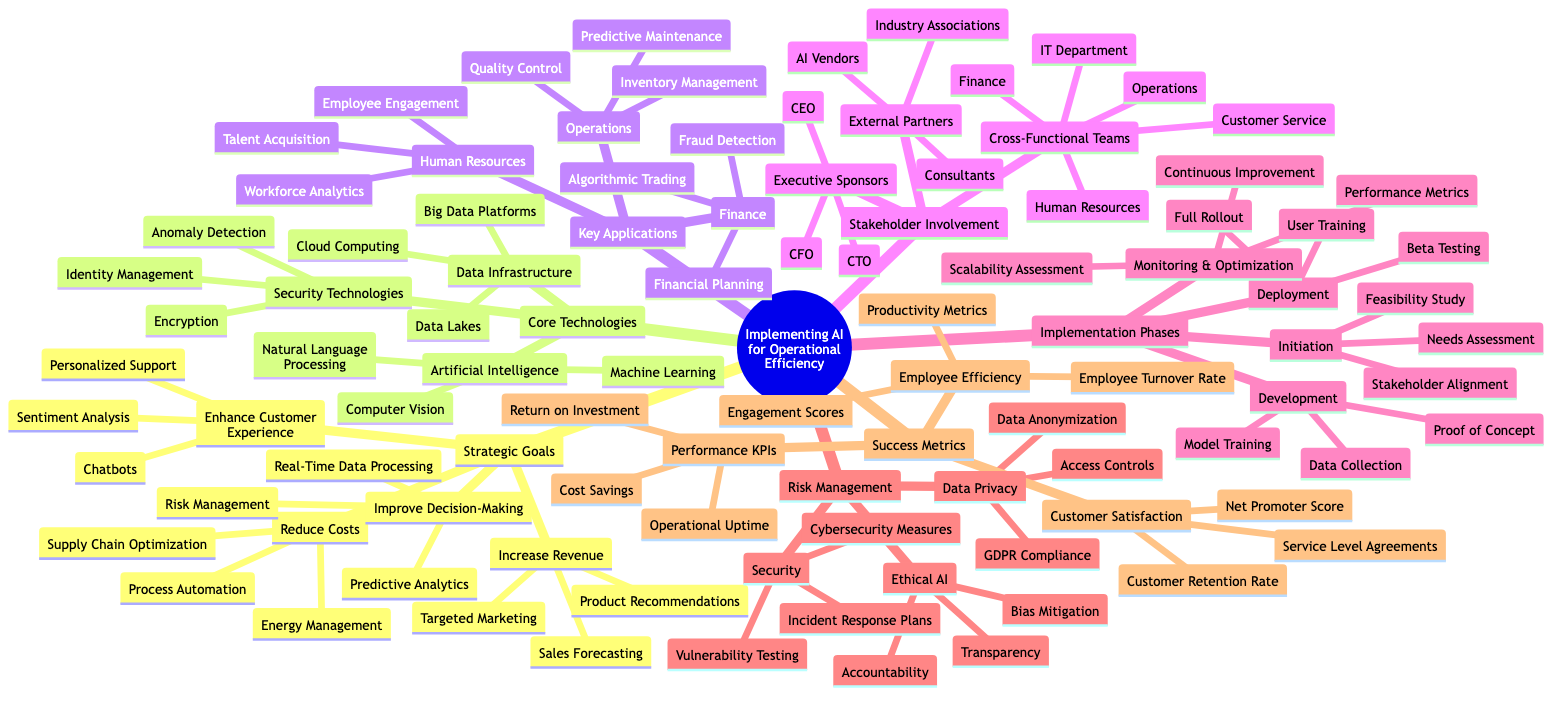What are the four strategic goals outlined in the mind map? The diagram lists four strategic goals: Increase Revenue, Reduce Costs, Enhance Customer Experience, and Improve Decision-Making.
Answer: Increase Revenue, Reduce Costs, Enhance Customer Experience, Improve Decision-Making How many core technologies are listed in the diagram? The mind map presents three core technology categories: Artificial Intelligence, Data Infrastructure, and Security Technologies. This totals to three categories.
Answer: Three What is the first application listed under Human Resources? The first application mentioned under Human Resources is Talent Acquisition.
Answer: Talent Acquisition What are the key applications in Operations? The mind map specifies three key applications within Operations: Predictive Maintenance, Inventory Management, and Quality Control.
Answer: Predictive Maintenance, Inventory Management, Quality Control How many implementation phases are described in the diagram? The diagram details four implementation phases: Initiation, Development, Deployment, Monitoring & Optimization. Thus, there are four phases.
Answer: Four Which security technology is named for ensuring data privacy? Data Anonymization is specifically mentioned under the Data Privacy category as a security technology to ensure data privacy.
Answer: Data Anonymization Which stakeholders are labeled as Executive Sponsors? The labels for Executive Sponsors include CEO, CFO, and CTO, representing the chief executives of an organization.
Answer: CEO, CFO, CTO What is the last risk management category focused on? The last category under Risk Management deals with Ethical AI, emphasizing ethical considerations in AI implementations.
Answer: Ethical AI How is customer satisfaction measured according to the success metrics? The mind map indicates that customer satisfaction metrics include Net Promoter Score, Customer Retention Rate, and Service Level Agreements.
Answer: Net Promoter Score, Customer Retention Rate, Service Level Agreements 